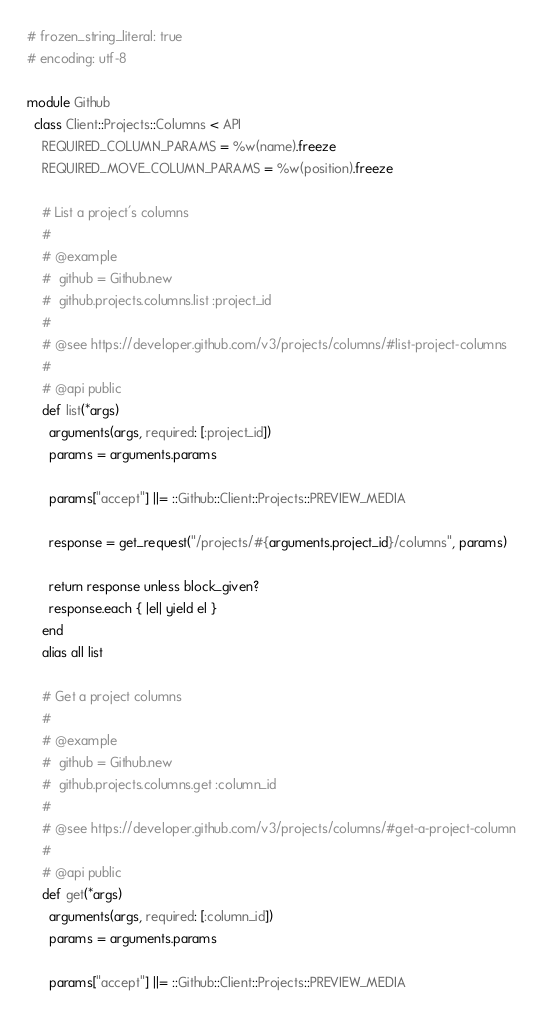Convert code to text. <code><loc_0><loc_0><loc_500><loc_500><_Ruby_># frozen_string_literal: true
# encoding: utf-8

module Github
  class Client::Projects::Columns < API
    REQUIRED_COLUMN_PARAMS = %w(name).freeze
    REQUIRED_MOVE_COLUMN_PARAMS = %w(position).freeze

    # List a project's columns
    #
    # @example
    #  github = Github.new
    #  github.projects.columns.list :project_id
    #
    # @see https://developer.github.com/v3/projects/columns/#list-project-columns
    #
    # @api public
    def list(*args)
      arguments(args, required: [:project_id])
      params = arguments.params

      params["accept"] ||= ::Github::Client::Projects::PREVIEW_MEDIA

      response = get_request("/projects/#{arguments.project_id}/columns", params)

      return response unless block_given?
      response.each { |el| yield el }
    end
    alias all list

    # Get a project columns
    #
    # @example
    #  github = Github.new
    #  github.projects.columns.get :column_id
    #
    # @see https://developer.github.com/v3/projects/columns/#get-a-project-column
    #
    # @api public
    def get(*args)
      arguments(args, required: [:column_id])
      params = arguments.params

      params["accept"] ||= ::Github::Client::Projects::PREVIEW_MEDIA
</code> 